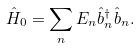Convert formula to latex. <formula><loc_0><loc_0><loc_500><loc_500>\hat { H } _ { 0 } = \sum _ { n } { E _ { n } \hat { b } ^ { \dagger } _ { n } \hat { b } _ { n } } .</formula> 